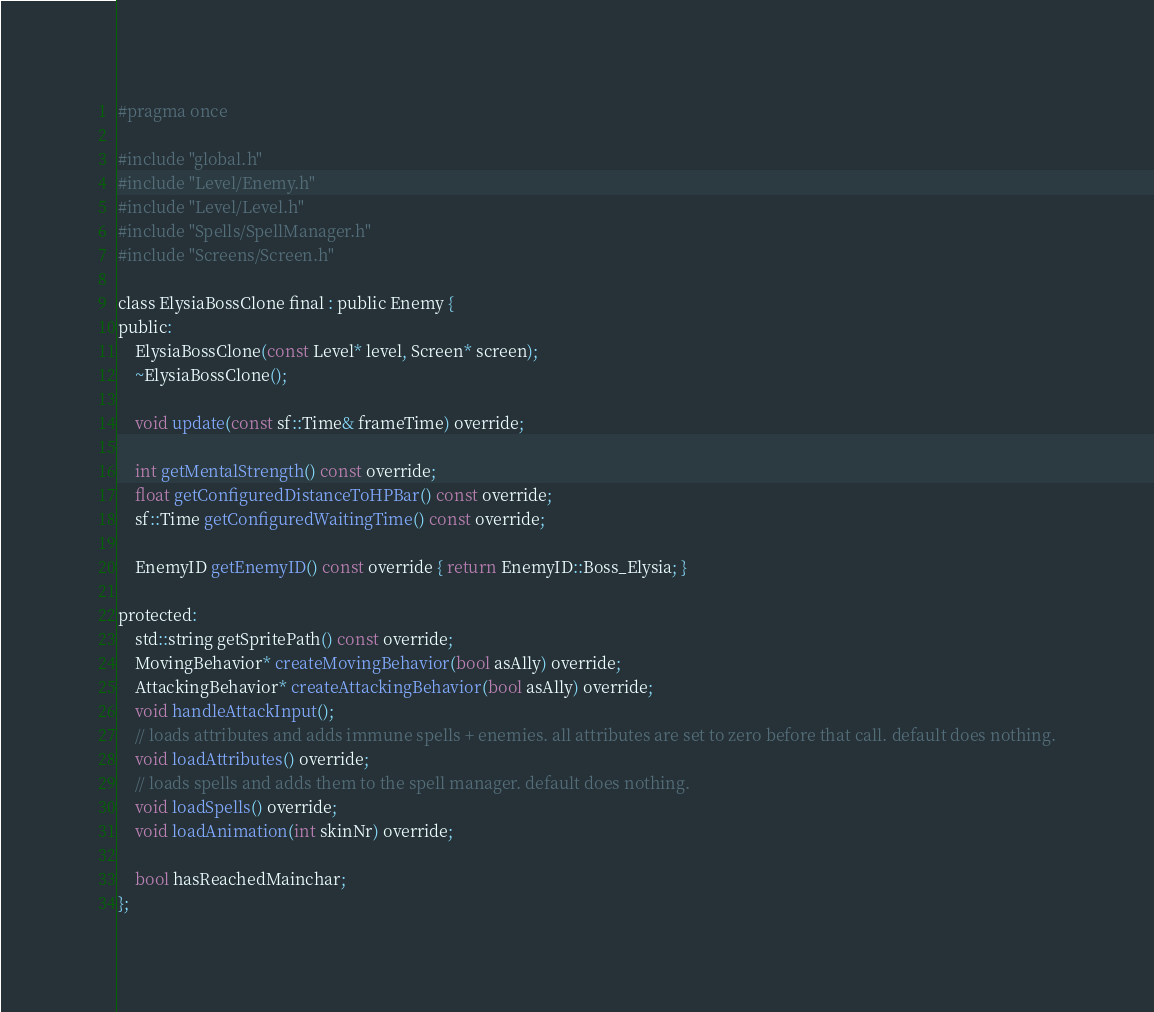Convert code to text. <code><loc_0><loc_0><loc_500><loc_500><_C_>#pragma once

#include "global.h"
#include "Level/Enemy.h"
#include "Level/Level.h"
#include "Spells/SpellManager.h"
#include "Screens/Screen.h"

class ElysiaBossClone final : public Enemy {
public:
	ElysiaBossClone(const Level* level, Screen* screen);
	~ElysiaBossClone();

	void update(const sf::Time& frameTime) override;

	int getMentalStrength() const override;
	float getConfiguredDistanceToHPBar() const override;
	sf::Time getConfiguredWaitingTime() const override;

	EnemyID getEnemyID() const override { return EnemyID::Boss_Elysia; }

protected:
	std::string getSpritePath() const override;
	MovingBehavior* createMovingBehavior(bool asAlly) override;
	AttackingBehavior* createAttackingBehavior(bool asAlly) override;
	void handleAttackInput();
	// loads attributes and adds immune spells + enemies. all attributes are set to zero before that call. default does nothing.
	void loadAttributes() override;
	// loads spells and adds them to the spell manager. default does nothing.
	void loadSpells() override;
	void loadAnimation(int skinNr) override;

	bool hasReachedMainchar;
};</code> 